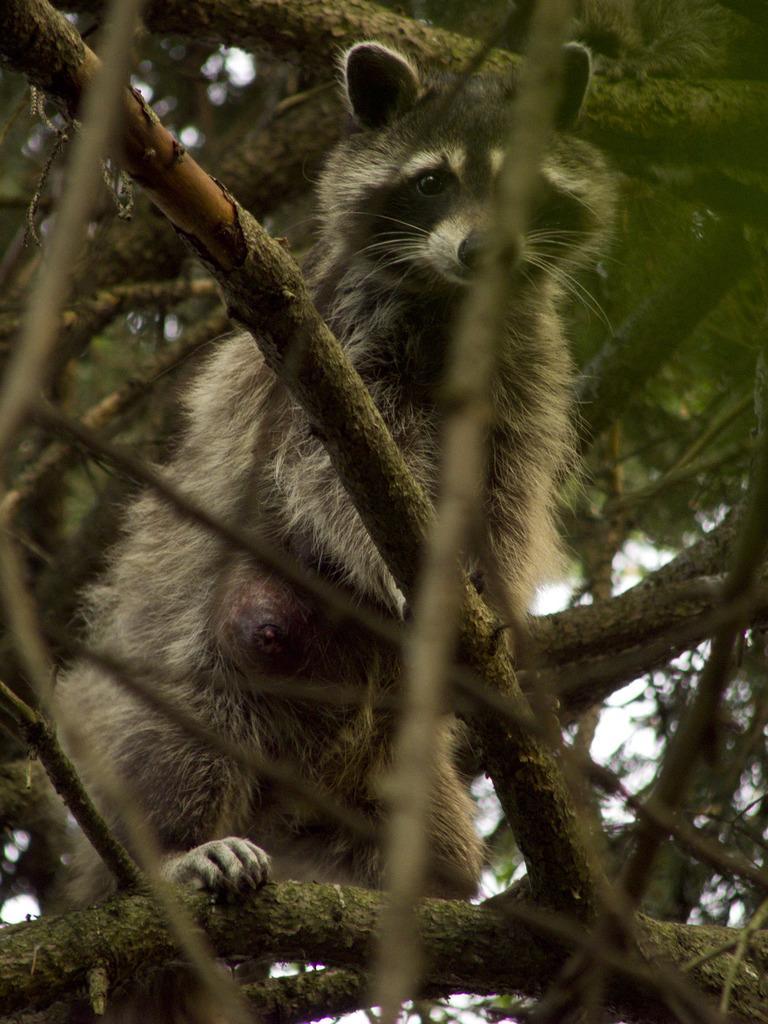Please provide a concise description of this image. In this picture we can see a brown color raccoons sitting on the tree branch. Behind there are some green leaf. 